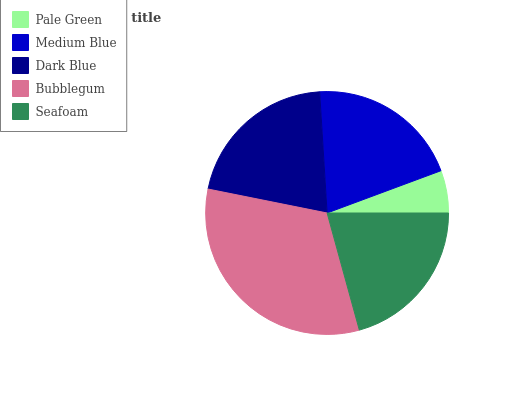Is Pale Green the minimum?
Answer yes or no. Yes. Is Bubblegum the maximum?
Answer yes or no. Yes. Is Medium Blue the minimum?
Answer yes or no. No. Is Medium Blue the maximum?
Answer yes or no. No. Is Medium Blue greater than Pale Green?
Answer yes or no. Yes. Is Pale Green less than Medium Blue?
Answer yes or no. Yes. Is Pale Green greater than Medium Blue?
Answer yes or no. No. Is Medium Blue less than Pale Green?
Answer yes or no. No. Is Seafoam the high median?
Answer yes or no. Yes. Is Seafoam the low median?
Answer yes or no. Yes. Is Medium Blue the high median?
Answer yes or no. No. Is Bubblegum the low median?
Answer yes or no. No. 